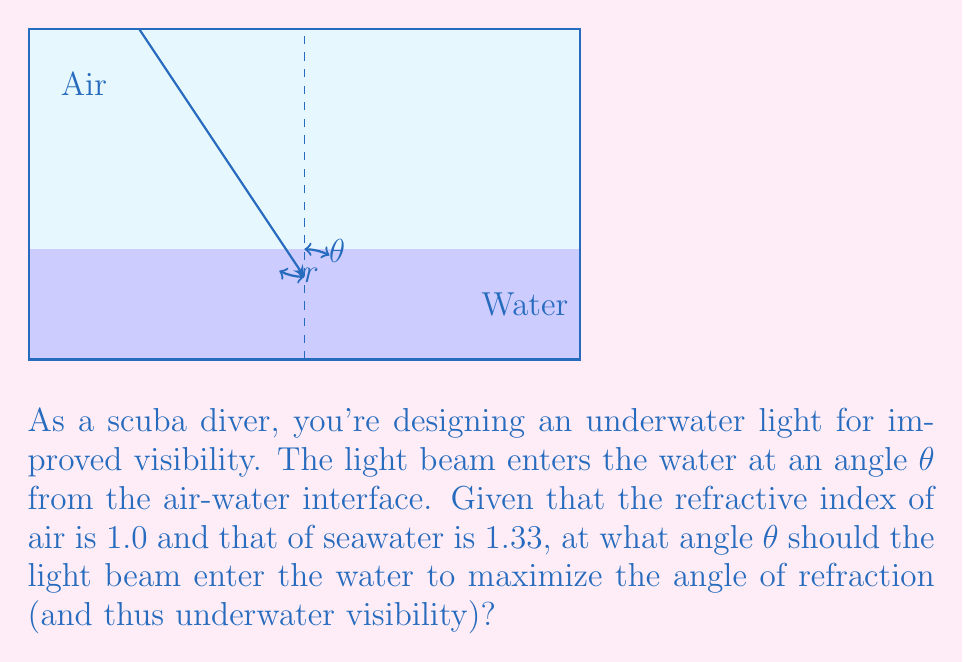Provide a solution to this math problem. Let's approach this step-by-step using Snell's law and optimization:

1) Snell's law states that $n_1 \sin(\theta_1) = n_2 \sin(\theta_2)$, where $n_1$ and $n_2$ are the refractive indices, and $\theta_1$ and $\theta_2$ are the angles of incidence and refraction respectively.

2) In this case, $n_1 = 1.0$ (air), $n_2 = 1.33$ (seawater), $\theta_1 = \theta$ (angle of incidence), and $\theta_2 = r$ (angle of refraction).

3) Applying Snell's law:

   $1.0 \sin(\theta) = 1.33 \sin(r)$

4) To maximize underwater visibility, we want to maximize $r$. The maximum value $r$ can take is 90° (parallel to the surface).

5) At this maximum:

   $1.0 \sin(\theta) = 1.33 \sin(90°) = 1.33$

6) Solving for $\theta$:

   $\sin(\theta) = 1.33$
   $\theta = \arcsin(1.33)$

7) However, $\sin(\theta)$ cannot exceed 1, so there's no real solution here. This means we need to find the angle that gets us as close to 90° as possible for $r$.

8) The maximum value of $\sin(\theta)$ is 1, which occurs when $\theta = 90°$.

9) Substituting this back into Snell's law:

   $1.0 \sin(90°) = 1.33 \sin(r)$
   $1 = 1.33 \sin(r)$
   $\sin(r) = \frac{1}{1.33} \approx 0.7519$
   $r = \arcsin(0.7519) \approx 48.75°$

10) Therefore, to maximize the angle of refraction (and thus underwater visibility), the light beam should enter the water at an angle of 90° from the normal (i.e., parallel to the water surface).
Answer: $\theta = 90°$ 